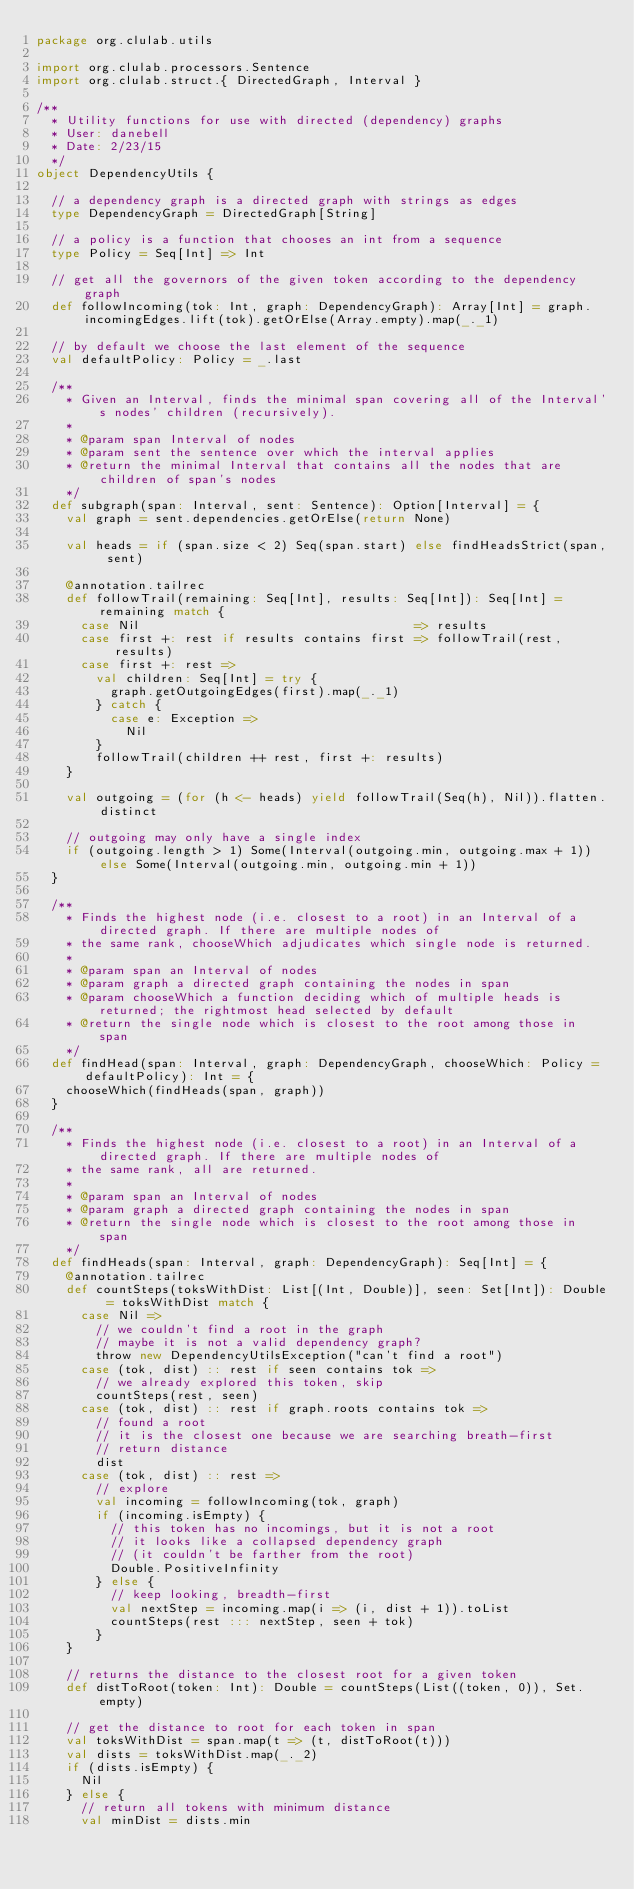<code> <loc_0><loc_0><loc_500><loc_500><_Scala_>package org.clulab.utils

import org.clulab.processors.Sentence
import org.clulab.struct.{ DirectedGraph, Interval }

/**
  * Utility functions for use with directed (dependency) graphs
  * User: danebell
  * Date: 2/23/15
  */
object DependencyUtils {

  // a dependency graph is a directed graph with strings as edges
  type DependencyGraph = DirectedGraph[String]

  // a policy is a function that chooses an int from a sequence
  type Policy = Seq[Int] => Int

  // get all the governors of the given token according to the dependency graph
  def followIncoming(tok: Int, graph: DependencyGraph): Array[Int] = graph.incomingEdges.lift(tok).getOrElse(Array.empty).map(_._1)

  // by default we choose the last element of the sequence
  val defaultPolicy: Policy = _.last

  /**
    * Given an Interval, finds the minimal span covering all of the Interval's nodes' children (recursively).
    *
    * @param span Interval of nodes
    * @param sent the sentence over which the interval applies
    * @return the minimal Interval that contains all the nodes that are children of span's nodes
    */
  def subgraph(span: Interval, sent: Sentence): Option[Interval] = {
    val graph = sent.dependencies.getOrElse(return None)

    val heads = if (span.size < 2) Seq(span.start) else findHeadsStrict(span, sent)

    @annotation.tailrec
    def followTrail(remaining: Seq[Int], results: Seq[Int]): Seq[Int] = remaining match {
      case Nil                                     => results
      case first +: rest if results contains first => followTrail(rest, results)
      case first +: rest =>
        val children: Seq[Int] = try {
          graph.getOutgoingEdges(first).map(_._1)
        } catch {
          case e: Exception =>
            Nil
        }
        followTrail(children ++ rest, first +: results)
    }

    val outgoing = (for (h <- heads) yield followTrail(Seq(h), Nil)).flatten.distinct

    // outgoing may only have a single index
    if (outgoing.length > 1) Some(Interval(outgoing.min, outgoing.max + 1)) else Some(Interval(outgoing.min, outgoing.min + 1))
  }

  /**
    * Finds the highest node (i.e. closest to a root) in an Interval of a directed graph. If there are multiple nodes of
    * the same rank, chooseWhich adjudicates which single node is returned.
    *
    * @param span an Interval of nodes
    * @param graph a directed graph containing the nodes in span
    * @param chooseWhich a function deciding which of multiple heads is returned; the rightmost head selected by default
    * @return the single node which is closest to the root among those in span
    */
  def findHead(span: Interval, graph: DependencyGraph, chooseWhich: Policy = defaultPolicy): Int = {
    chooseWhich(findHeads(span, graph))
  }

  /**
    * Finds the highest node (i.e. closest to a root) in an Interval of a directed graph. If there are multiple nodes of
    * the same rank, all are returned.
    *
    * @param span an Interval of nodes
    * @param graph a directed graph containing the nodes in span
    * @return the single node which is closest to the root among those in span
    */
  def findHeads(span: Interval, graph: DependencyGraph): Seq[Int] = {
    @annotation.tailrec
    def countSteps(toksWithDist: List[(Int, Double)], seen: Set[Int]): Double = toksWithDist match {
      case Nil =>
        // we couldn't find a root in the graph
        // maybe it is not a valid dependency graph?
        throw new DependencyUtilsException("can't find a root")
      case (tok, dist) :: rest if seen contains tok =>
        // we already explored this token, skip
        countSteps(rest, seen)
      case (tok, dist) :: rest if graph.roots contains tok =>
        // found a root
        // it is the closest one because we are searching breath-first
        // return distance
        dist
      case (tok, dist) :: rest =>
        // explore
        val incoming = followIncoming(tok, graph)
        if (incoming.isEmpty) {
          // this token has no incomings, but it is not a root
          // it looks like a collapsed dependency graph
          // (it couldn't be farther from the root)
          Double.PositiveInfinity
        } else {
          // keep looking, breadth-first
          val nextStep = incoming.map(i => (i, dist + 1)).toList
          countSteps(rest ::: nextStep, seen + tok)
        }
    }

    // returns the distance to the closest root for a given token
    def distToRoot(token: Int): Double = countSteps(List((token, 0)), Set.empty)

    // get the distance to root for each token in span
    val toksWithDist = span.map(t => (t, distToRoot(t)))
    val dists = toksWithDist.map(_._2)
    if (dists.isEmpty) {
      Nil
    } else {
      // return all tokens with minimum distance
      val minDist = dists.min</code> 